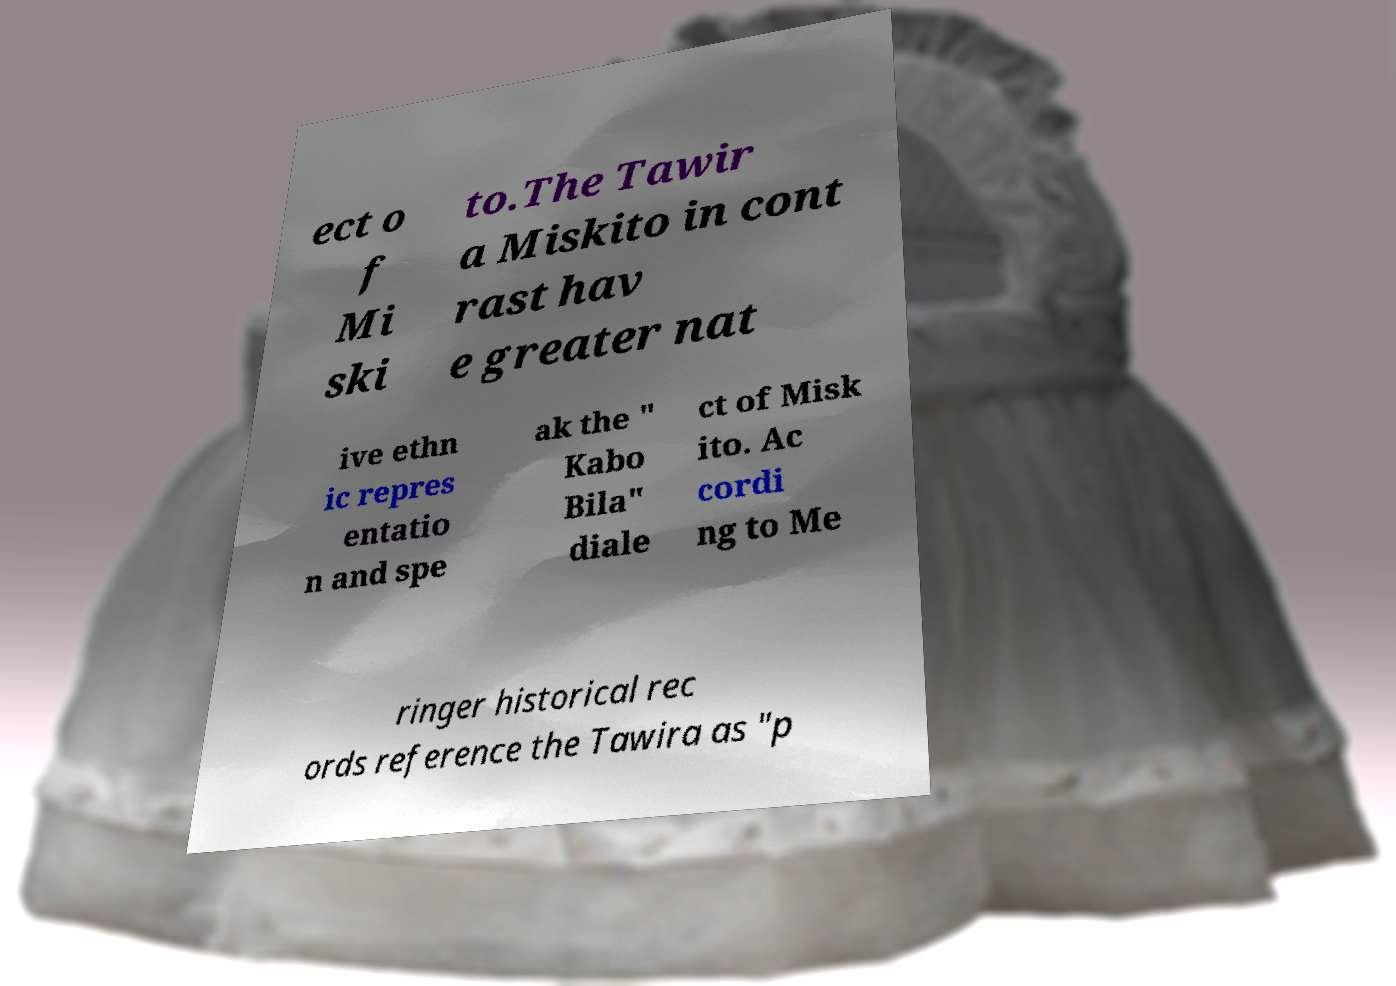Could you extract and type out the text from this image? ect o f Mi ski to.The Tawir a Miskito in cont rast hav e greater nat ive ethn ic repres entatio n and spe ak the " Kabo Bila" diale ct of Misk ito. Ac cordi ng to Me ringer historical rec ords reference the Tawira as "p 